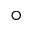Convert formula to latex. <formula><loc_0><loc_0><loc_500><loc_500>^ { \circ }</formula> 